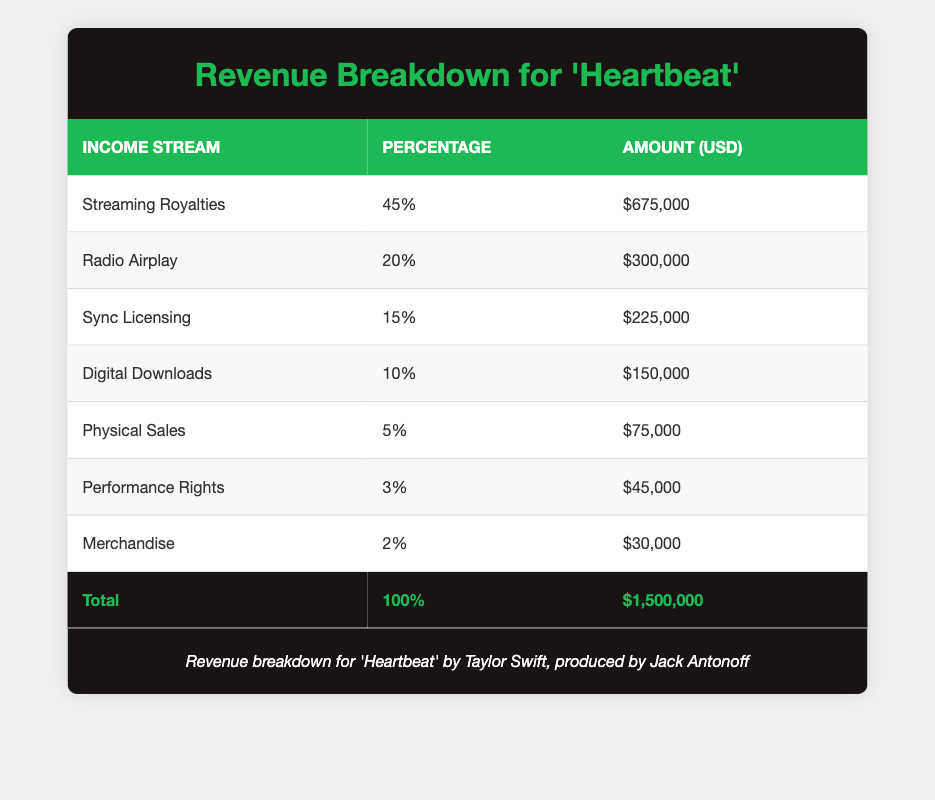What is the total revenue generated from the single? The total revenue is explicitly stated in the ‘Total’ row of the table, which indicates $1,500,000.
Answer: $1,500,000 What percentage of the revenue comes from streaming royalties? The percentage for streaming royalties is listed in the table as 45%.
Answer: 45% Is the amount generated from merchandise sales more than the amount from performance rights? According to the table, merchandise sales generate $30,000, while performance rights generate $45,000. This indicates that performance rights generate more than merchandise.
Answer: Yes What is the difference in revenue between radio airplay and sync licensing? The revenue from radio airplay is $300,000 and from sync licensing is $225,000. The difference is $300,000 - $225,000 = $75,000.
Answer: $75,000 If we combine the revenue from digital downloads and physical sales, what is the total? The amount generated from digital downloads is $150,000 and from physical sales is $75,000. Adding these together gives $150,000 + $75,000 = $225,000.
Answer: $225,000 What income stream contributes the least percentage to the total revenue? The table shows that merchandise contributes 2%, which is the lowest percentage compared to the other streams.
Answer: Merchandise Is the revenue from streaming royalties greater than the combined revenue from physical sales and performance rights? Streaming royalties generate $675,000, while physical sales and performance rights combined generate $75,000 + $45,000 = $120,000. Since $675,000 is greater than $120,000, the statement is correct.
Answer: Yes What percentage does the sync licensing account for when compared to the total revenue? Sync licensing accounts for 15% of the total revenue, which is directly provided in the table.
Answer: 15% How does the percentage of revenue from digital downloads compare to the total revenue from merchandise and performance rights combined? Digital downloads account for 10%, while merchandise (2%) and performance rights (3%) combined total 5%. Since 10% is greater than 5%, digital downloads contribute more.
Answer: Yes 